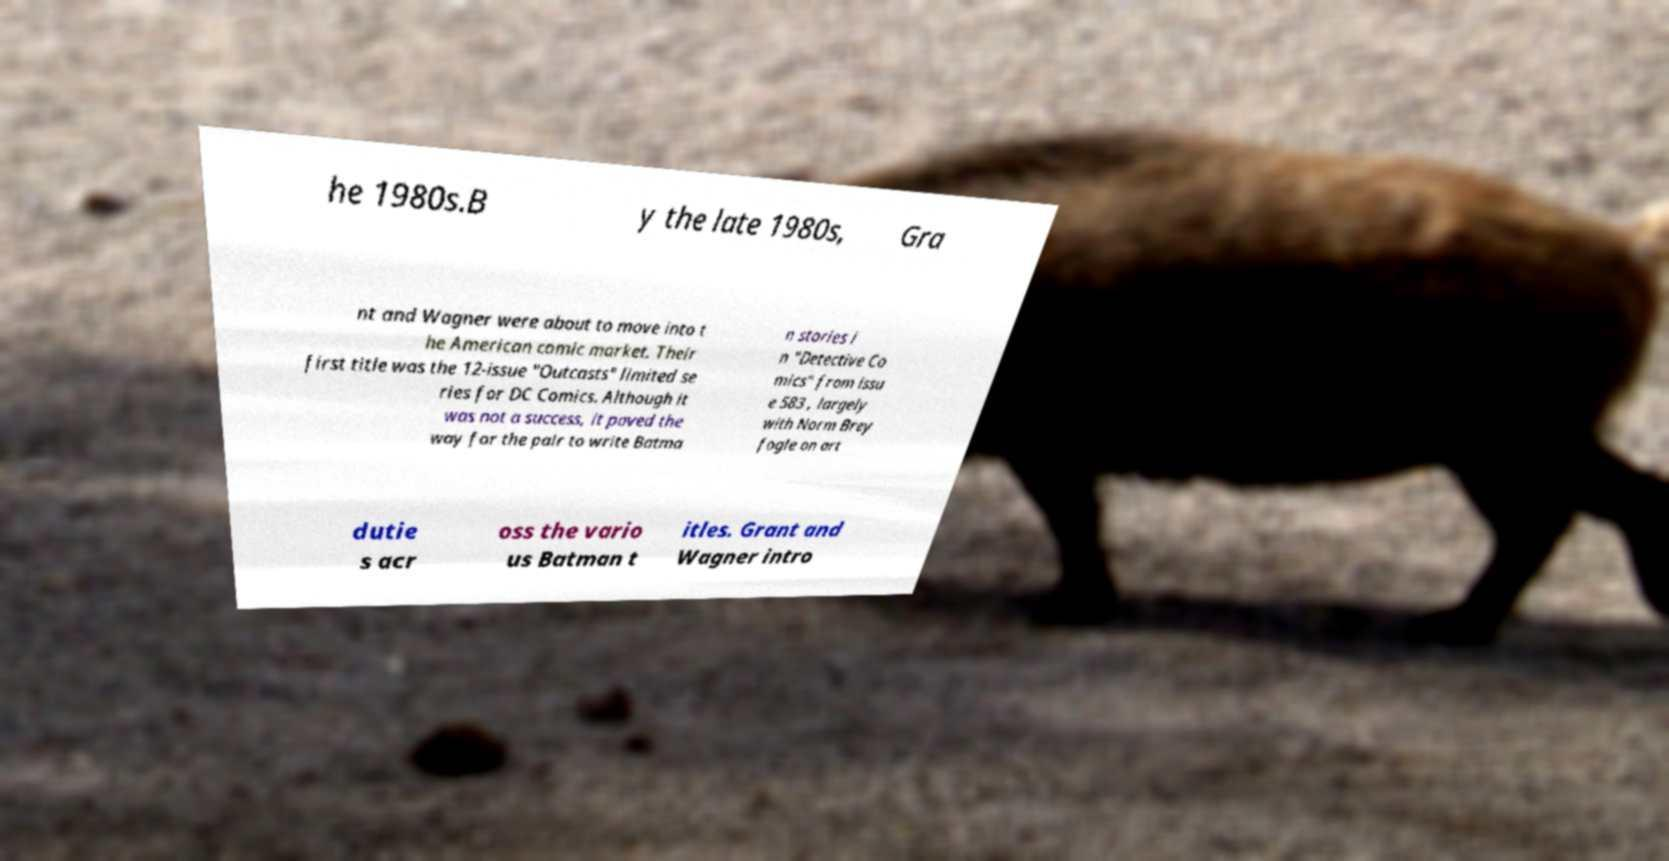What messages or text are displayed in this image? I need them in a readable, typed format. he 1980s.B y the late 1980s, Gra nt and Wagner were about to move into t he American comic market. Their first title was the 12-issue "Outcasts" limited se ries for DC Comics. Although it was not a success, it paved the way for the pair to write Batma n stories i n "Detective Co mics" from issu e 583 , largely with Norm Brey fogle on art dutie s acr oss the vario us Batman t itles. Grant and Wagner intro 